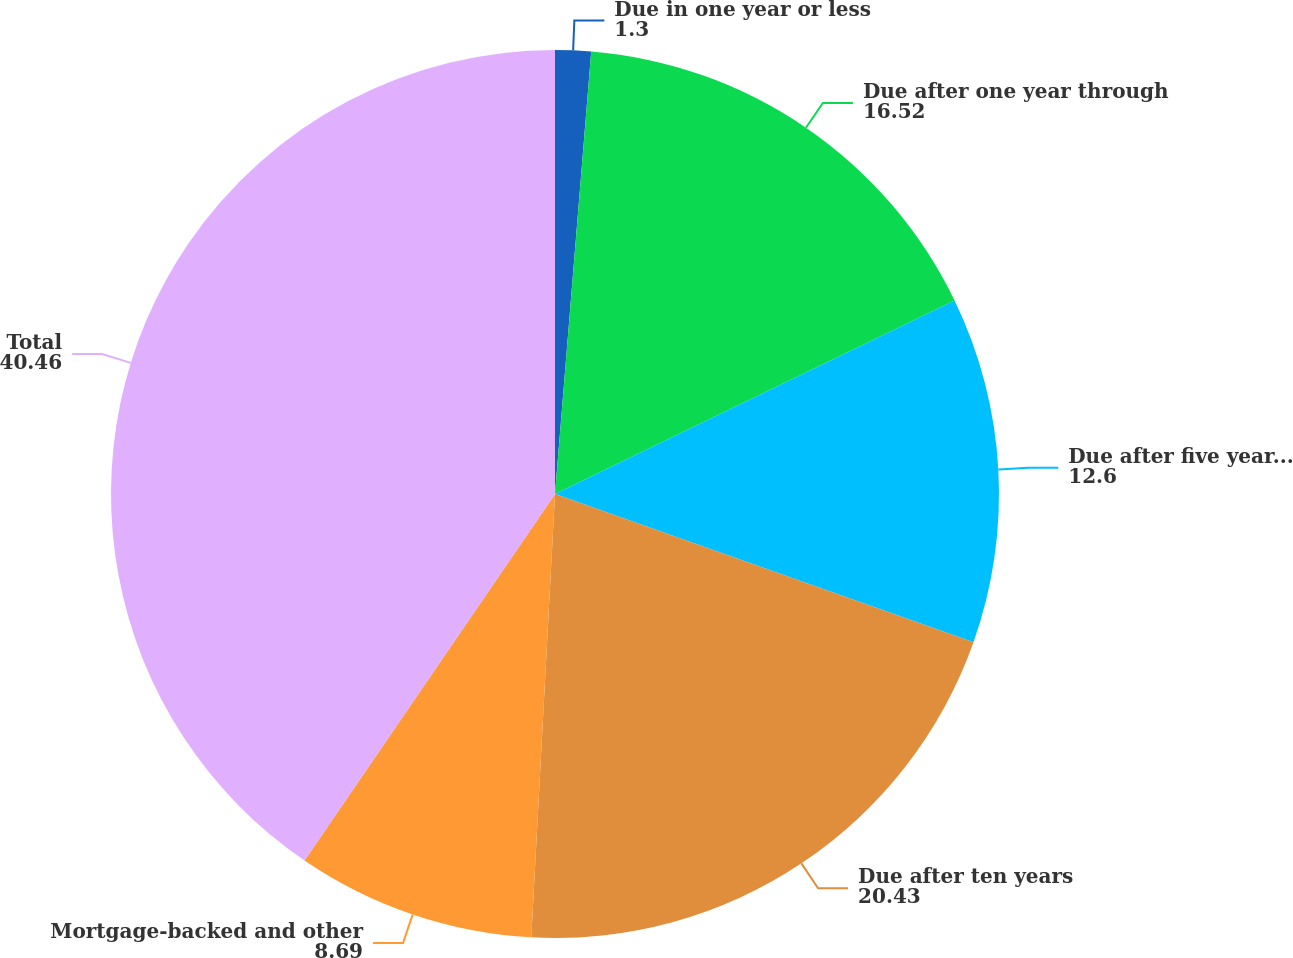<chart> <loc_0><loc_0><loc_500><loc_500><pie_chart><fcel>Due in one year or less<fcel>Due after one year through<fcel>Due after five years through<fcel>Due after ten years<fcel>Mortgage-backed and other<fcel>Total<nl><fcel>1.3%<fcel>16.52%<fcel>12.6%<fcel>20.43%<fcel>8.69%<fcel>40.46%<nl></chart> 